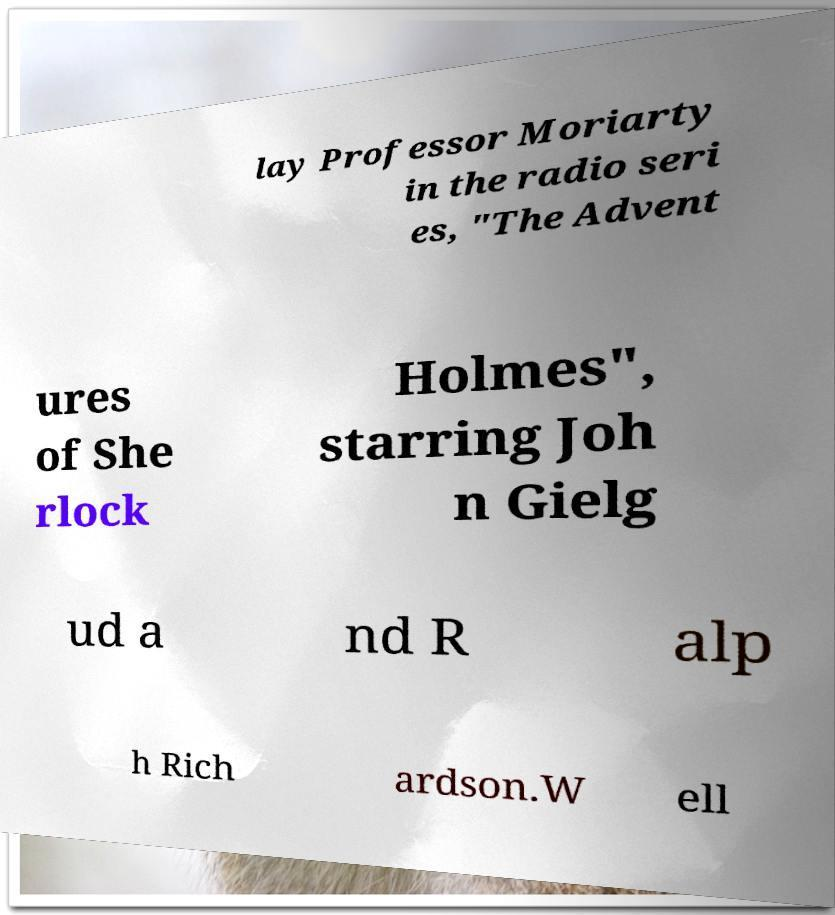Could you assist in decoding the text presented in this image and type it out clearly? lay Professor Moriarty in the radio seri es, "The Advent ures of She rlock Holmes", starring Joh n Gielg ud a nd R alp h Rich ardson.W ell 